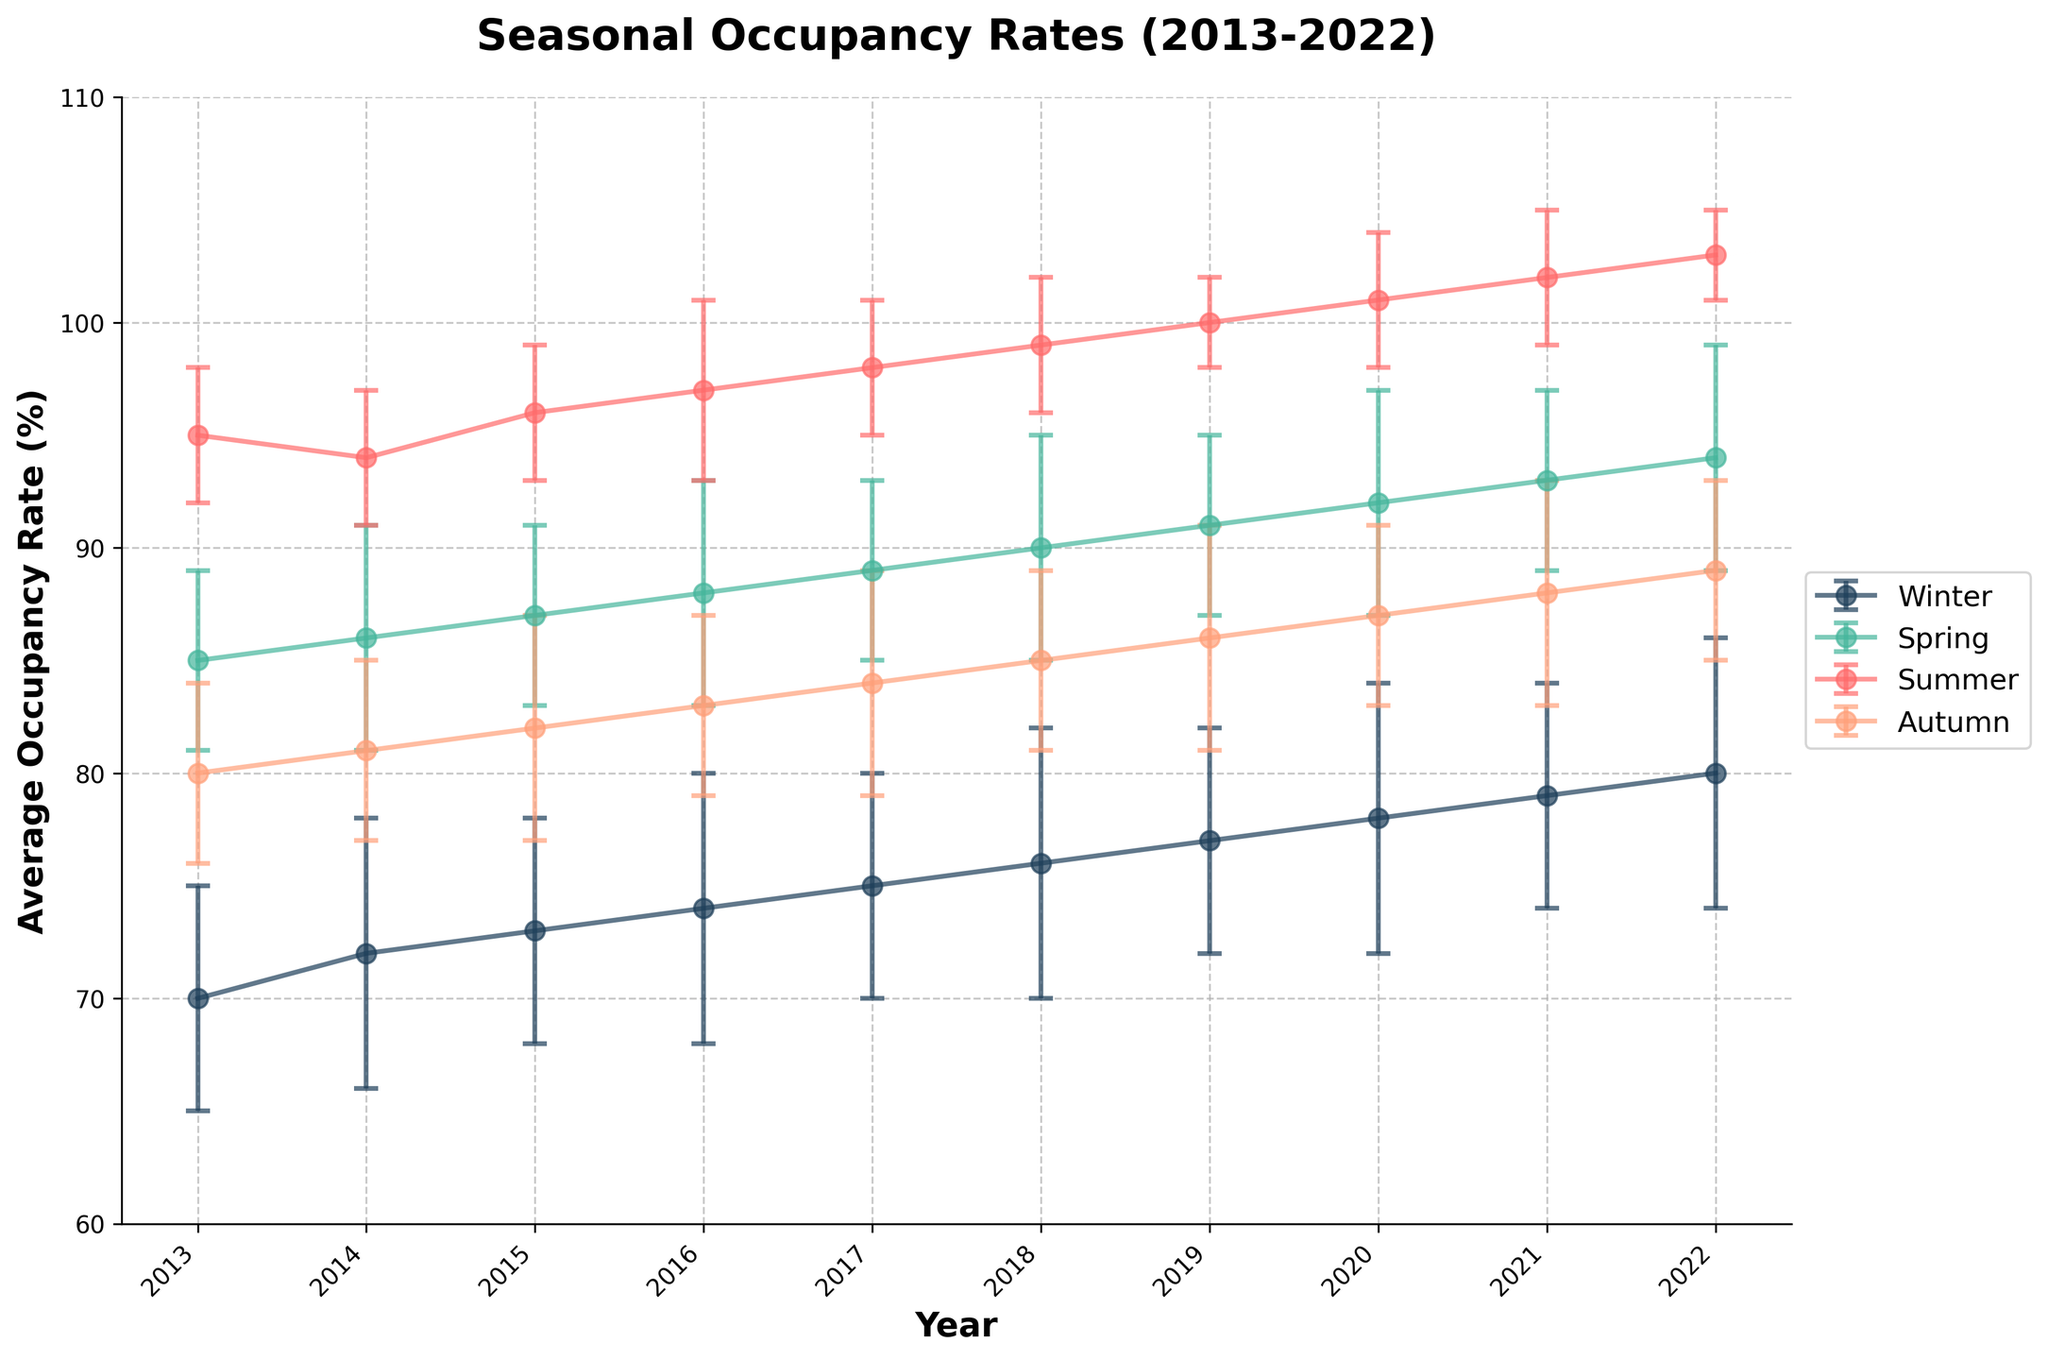What is the title of the plot? The title of the plot is usually located at the top of the figure. It often provides a summary of what the plot represents. By looking at the top of the figure, you can see that the title is "Seasonal Occupancy Rates (2013-2022)."
Answer: Seasonal Occupancy Rates (2013-2022) What is the average occupancy rate for Winter in 2018? The plot shows different lines for each season. Locate the line for Winter, follow it to the year 2018, and check the y-value of the point. The point for Winter 2018 reaches the value 76 on the vertical axis.
Answer: 76 Which season showed the highest average occupancy rate in 2019? Each line represents a season, and the highest value across all lines for 2019 needs to be identified. The line representing Summer reaches 100 in 2019, which is higher than the other seasons.
Answer: Summer By how much did the average occupancy rate increase in Spring from 2015 to 2020? Locate the Spring line and check the y-values for 2015 and 2020. In 2015, Spring's average occupancy rate is 87, and in 2020, it is 92. The increase is 92 - 87 = 5.
Answer: 5 What is the overall trend in occupancy rates for Summer from 2013 to 2022? Look at the Summer line from 2013 to 2022. The line consistently goes upward from 95 in 2013 to 103 in 2022, indicating an increasing trend.
Answer: Increasing In which year did Autumn have the lowest average occupancy rate? Follow the Autumn line across all years and identify the lowest point. The lowest value for Autumn is 80, occurring in 2013.
Answer: 2013 Are the error bars for Winter generally larger or smaller than those for Summer? Compare the length of the error bars (vertical lines with caps) between Winter and Summer. Winter error bars appear longer on average compared to Summer.
Answer: Larger By how much did the average occupancy rate for Winter change from 2013 to 2022? Compare the values for Winter in 2013 and 2022. In 2013, Winter's average rate is 70, and in 2022, it is 80. The change is 80 - 70 = 10.
Answer: 10 How does the average occupancy rate in Autumn 2016 compare to Spring 2016? Locate the points for Autumn and Spring in 2016. Autumn has a rate of 83, while Spring has a rate of 88. Autumn's rate is 5 less than Spring's.
Answer: 5 less Which season shows the smallest variability in occupancy rates over the decade? The season with the smallest variability will have the shortest error bars across most years. Compare the lengths of error bars across all seasons. Summer has the shortest error bars, indicating the smallest variability.
Answer: Summer 